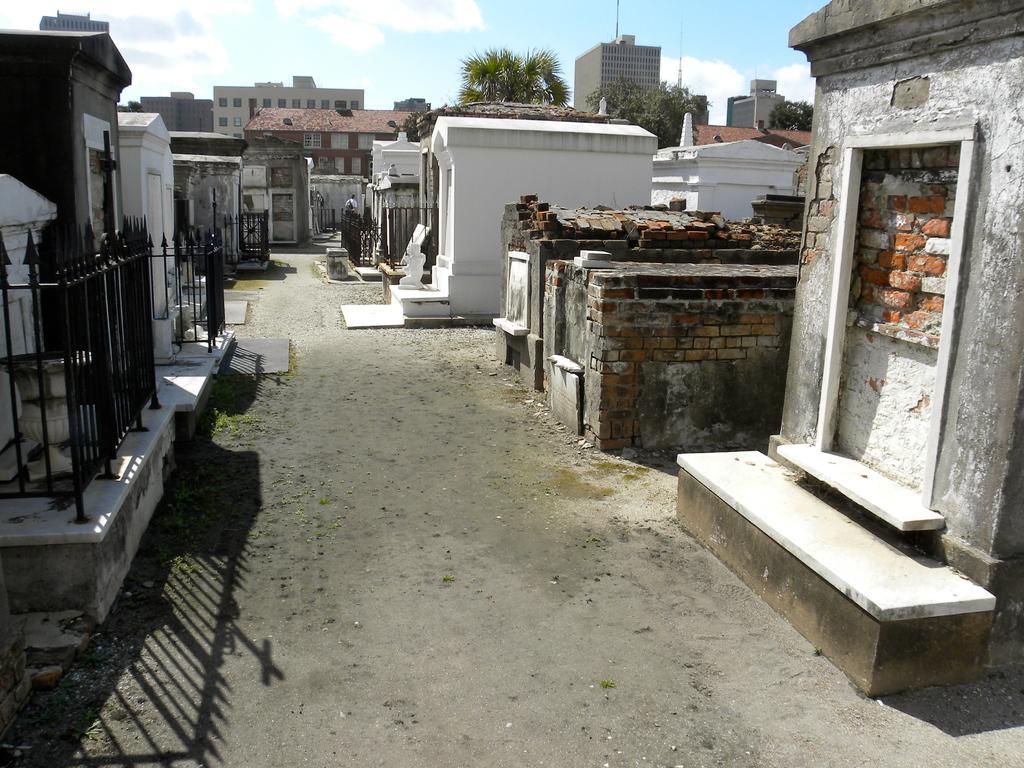Could you give a brief overview of what you see in this image? In this picture I can see houses, trees, iron grilles, and in the background there is sky. 